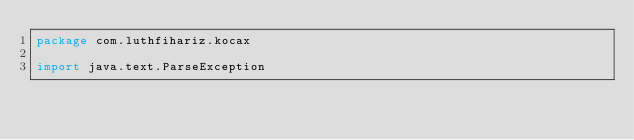<code> <loc_0><loc_0><loc_500><loc_500><_Kotlin_>package com.luthfihariz.kocax

import java.text.ParseException</code> 